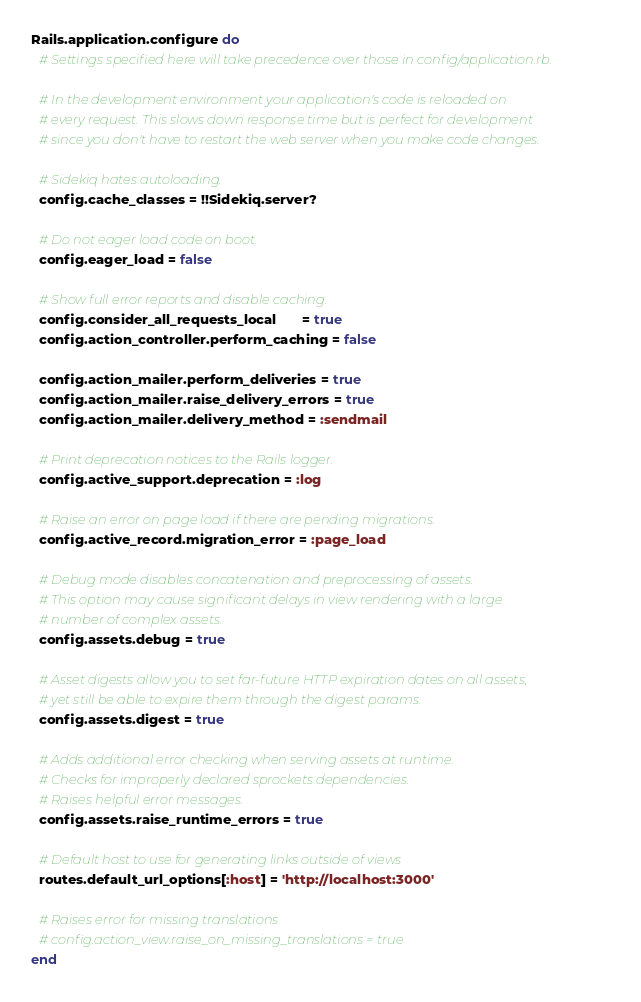<code> <loc_0><loc_0><loc_500><loc_500><_Ruby_>Rails.application.configure do
  # Settings specified here will take precedence over those in config/application.rb.

  # In the development environment your application's code is reloaded on
  # every request. This slows down response time but is perfect for development
  # since you don't have to restart the web server when you make code changes.

  # Sidekiq hates autoloading.
  config.cache_classes = !!Sidekiq.server?

  # Do not eager load code on boot.
  config.eager_load = false

  # Show full error reports and disable caching.
  config.consider_all_requests_local       = true
  config.action_controller.perform_caching = false

  config.action_mailer.perform_deliveries = true
  config.action_mailer.raise_delivery_errors = true
  config.action_mailer.delivery_method = :sendmail

  # Print deprecation notices to the Rails logger.
  config.active_support.deprecation = :log

  # Raise an error on page load if there are pending migrations.
  config.active_record.migration_error = :page_load

  # Debug mode disables concatenation and preprocessing of assets.
  # This option may cause significant delays in view rendering with a large
  # number of complex assets.
  config.assets.debug = true

  # Asset digests allow you to set far-future HTTP expiration dates on all assets,
  # yet still be able to expire them through the digest params.
  config.assets.digest = true

  # Adds additional error checking when serving assets at runtime.
  # Checks for improperly declared sprockets dependencies.
  # Raises helpful error messages.
  config.assets.raise_runtime_errors = true

  # Default host to use for generating links outside of views
  routes.default_url_options[:host] = 'http://localhost:3000'

  # Raises error for missing translations
  # config.action_view.raise_on_missing_translations = true
end
</code> 